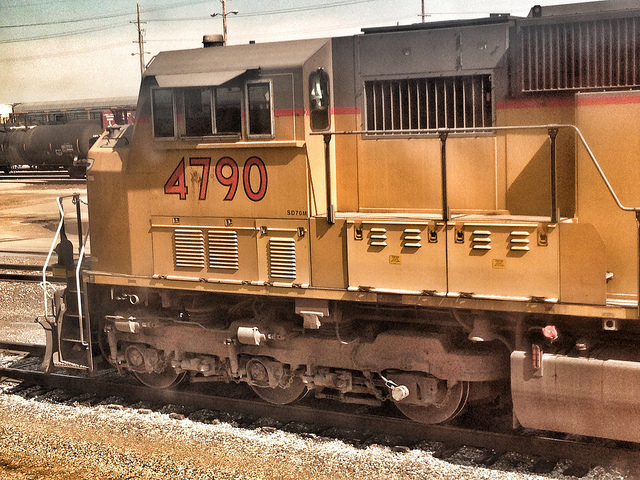Read all the text in this image. 4790 